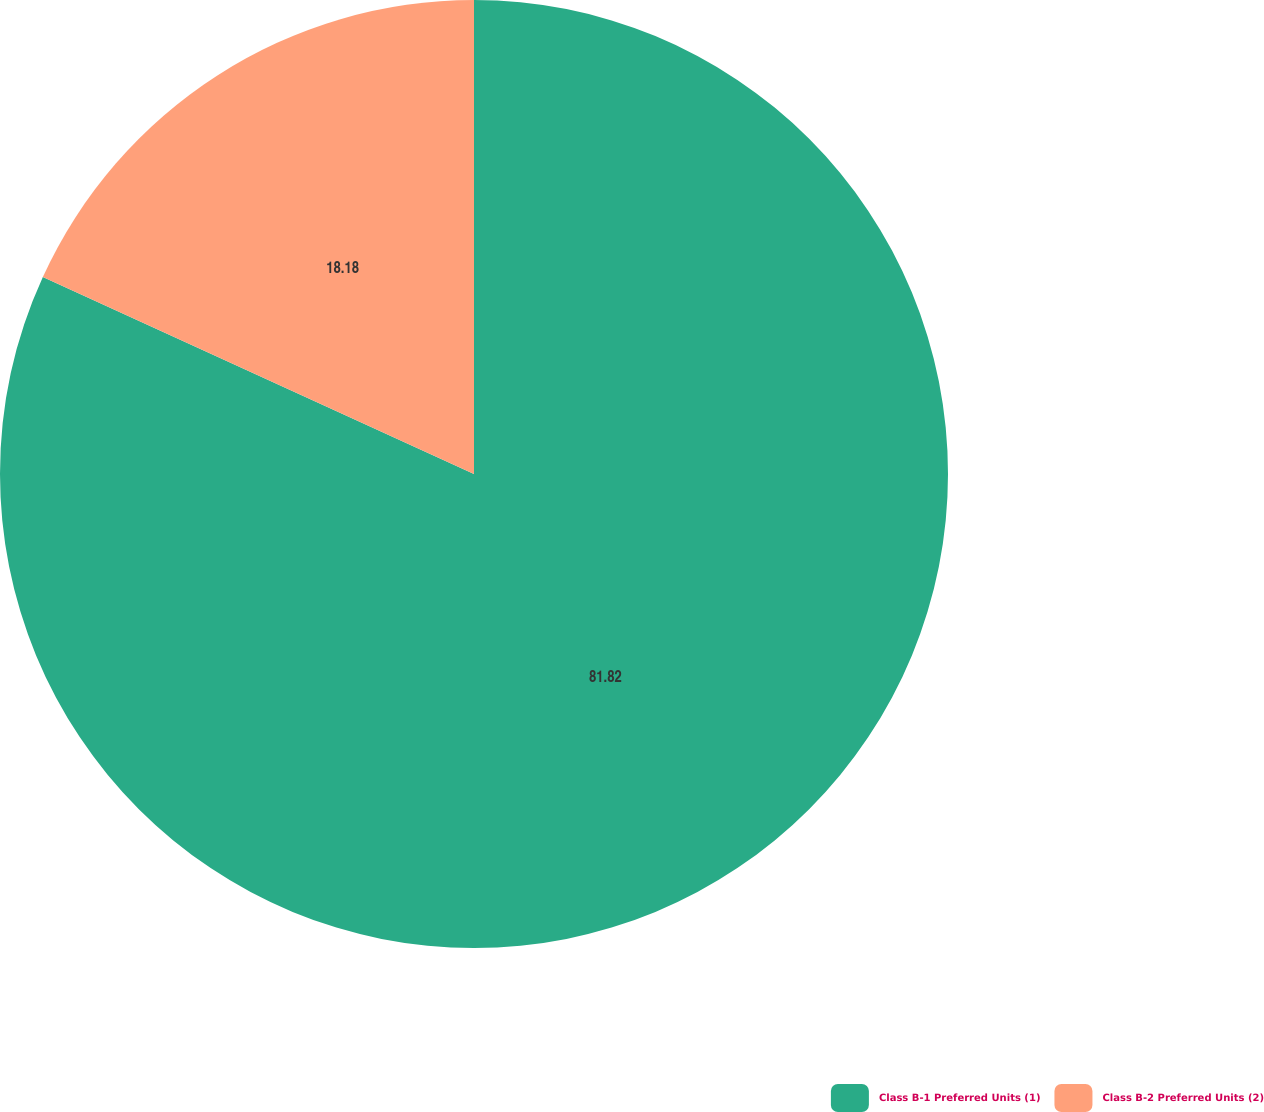<chart> <loc_0><loc_0><loc_500><loc_500><pie_chart><fcel>Class B-1 Preferred Units (1)<fcel>Class B-2 Preferred Units (2)<nl><fcel>81.82%<fcel>18.18%<nl></chart> 